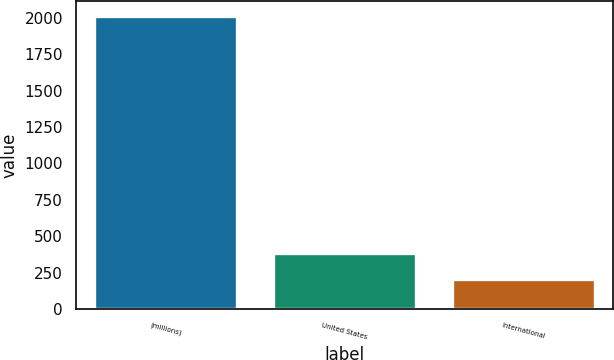Convert chart to OTSL. <chart><loc_0><loc_0><loc_500><loc_500><bar_chart><fcel>(millions)<fcel>United States<fcel>International<nl><fcel>2016<fcel>386.91<fcel>205.9<nl></chart> 